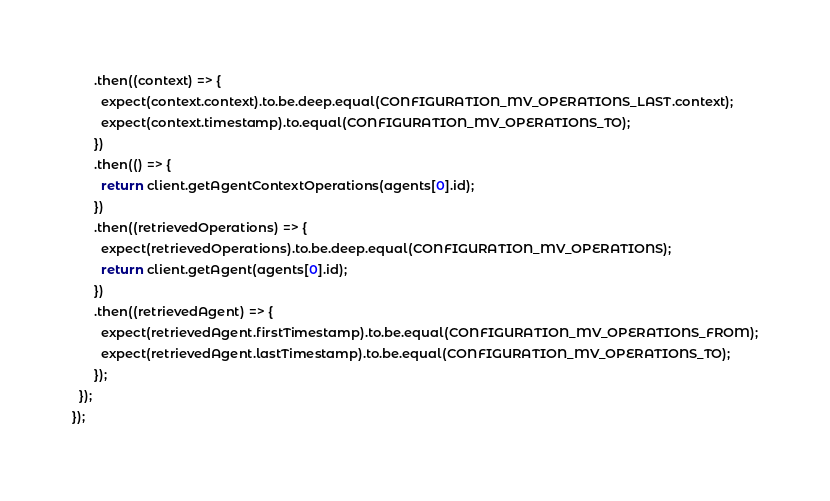Convert code to text. <code><loc_0><loc_0><loc_500><loc_500><_JavaScript_>      .then((context) => {
        expect(context.context).to.be.deep.equal(CONFIGURATION_MV_OPERATIONS_LAST.context);
        expect(context.timestamp).to.equal(CONFIGURATION_MV_OPERATIONS_TO);
      })
      .then(() => {
        return client.getAgentContextOperations(agents[0].id);
      })
      .then((retrievedOperations) => {
        expect(retrievedOperations).to.be.deep.equal(CONFIGURATION_MV_OPERATIONS);
        return client.getAgent(agents[0].id);
      })
      .then((retrievedAgent) => {
        expect(retrievedAgent.firstTimestamp).to.be.equal(CONFIGURATION_MV_OPERATIONS_FROM);
        expect(retrievedAgent.lastTimestamp).to.be.equal(CONFIGURATION_MV_OPERATIONS_TO);
      });
  });
});
</code> 